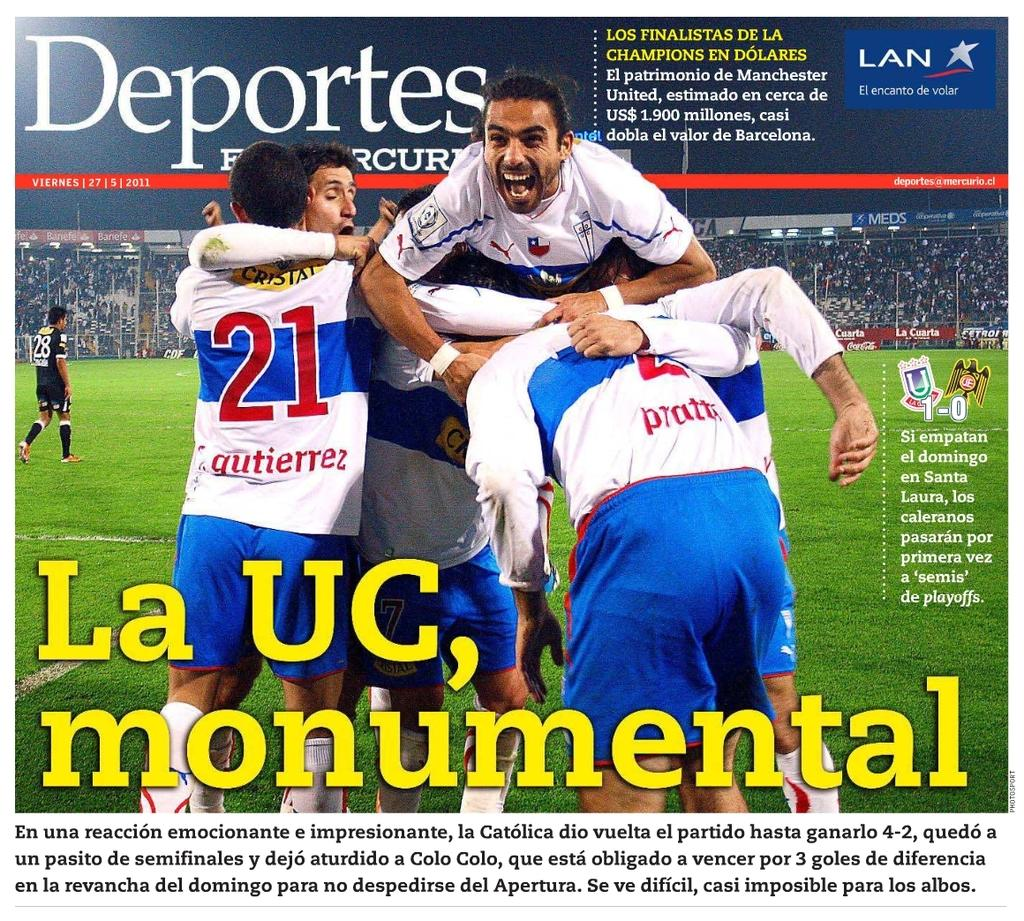<image>
Write a terse but informative summary of the picture. A soccer player wearing a jersey depicting the number 21 on the back hugs his teammates. 